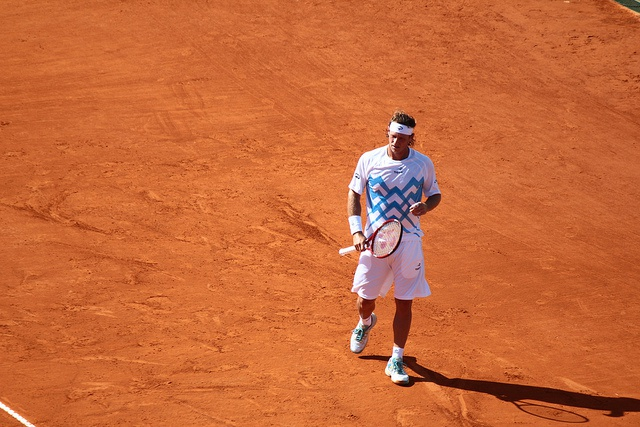Describe the objects in this image and their specific colors. I can see people in red, white, darkgray, maroon, and gray tones and tennis racket in red, lightpink, lightgray, maroon, and black tones in this image. 